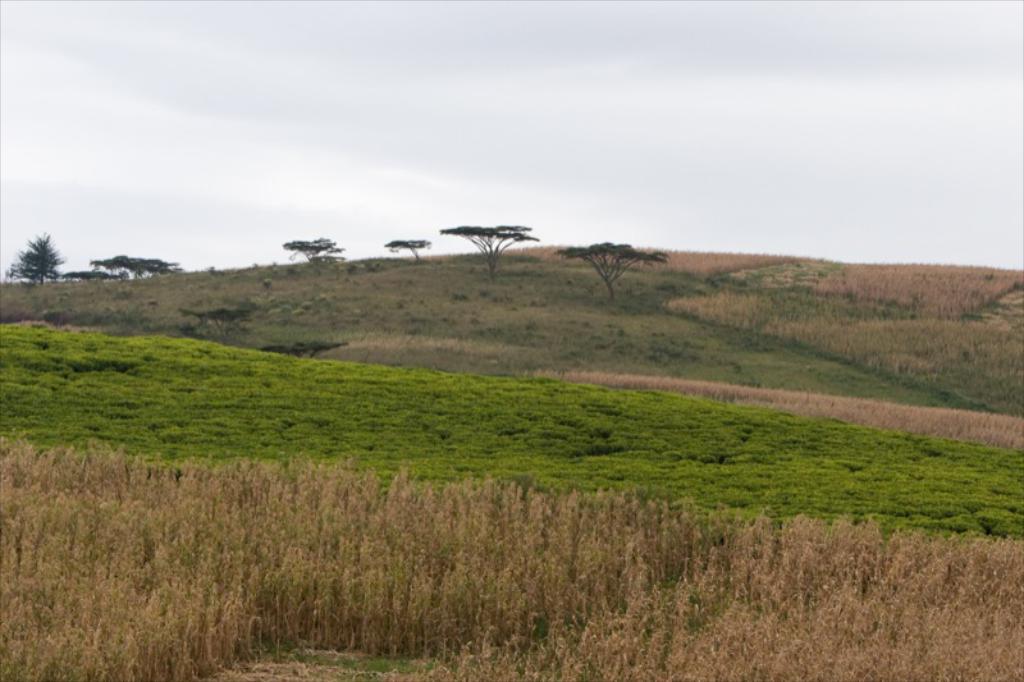Please provide a concise description of this image. In this picture I can see the farmland. At the bottom I can see the plants and grass. In the background I can see the mountain and trees. At the top I can see the sky and clouds. 